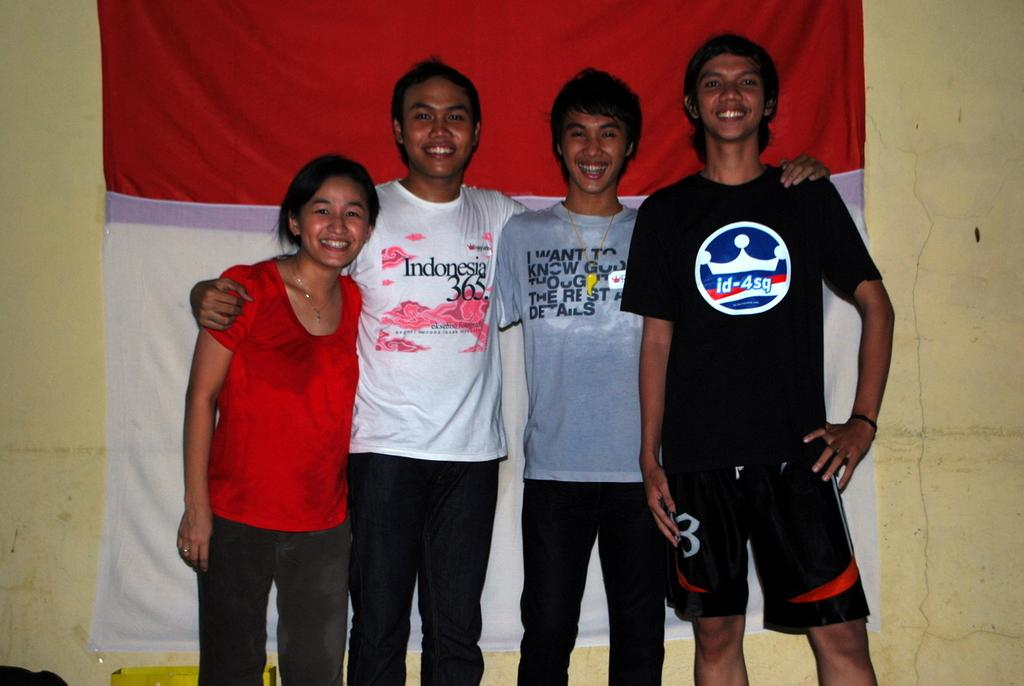<image>
Render a clear and concise summary of the photo. The man in the Indonesia 365 T-shirt poses beside a young woman and 2 other men. 